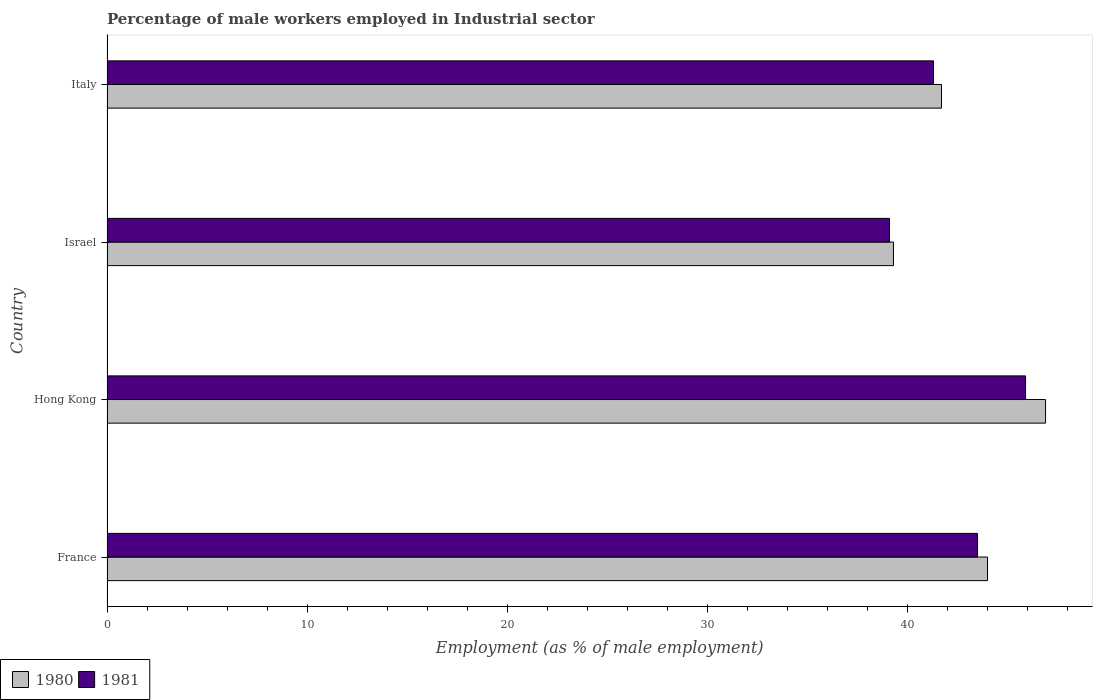How many different coloured bars are there?
Keep it short and to the point. 2. Are the number of bars on each tick of the Y-axis equal?
Ensure brevity in your answer.  Yes. How many bars are there on the 3rd tick from the bottom?
Offer a very short reply. 2. What is the label of the 4th group of bars from the top?
Your answer should be compact. France. In how many cases, is the number of bars for a given country not equal to the number of legend labels?
Keep it short and to the point. 0. What is the percentage of male workers employed in Industrial sector in 1981 in Hong Kong?
Provide a short and direct response. 45.9. Across all countries, what is the maximum percentage of male workers employed in Industrial sector in 1981?
Make the answer very short. 45.9. Across all countries, what is the minimum percentage of male workers employed in Industrial sector in 1980?
Offer a terse response. 39.3. In which country was the percentage of male workers employed in Industrial sector in 1981 maximum?
Ensure brevity in your answer.  Hong Kong. What is the total percentage of male workers employed in Industrial sector in 1981 in the graph?
Your answer should be compact. 169.8. What is the difference between the percentage of male workers employed in Industrial sector in 1981 in Israel and that in Italy?
Provide a short and direct response. -2.2. What is the difference between the percentage of male workers employed in Industrial sector in 1980 in Hong Kong and the percentage of male workers employed in Industrial sector in 1981 in Italy?
Your response must be concise. 5.6. What is the average percentage of male workers employed in Industrial sector in 1980 per country?
Your answer should be compact. 42.98. In how many countries, is the percentage of male workers employed in Industrial sector in 1980 greater than 34 %?
Ensure brevity in your answer.  4. What is the ratio of the percentage of male workers employed in Industrial sector in 1980 in Israel to that in Italy?
Provide a succinct answer. 0.94. Is the percentage of male workers employed in Industrial sector in 1981 in Israel less than that in Italy?
Your response must be concise. Yes. Is the difference between the percentage of male workers employed in Industrial sector in 1981 in France and Israel greater than the difference between the percentage of male workers employed in Industrial sector in 1980 in France and Israel?
Your answer should be very brief. No. What is the difference between the highest and the second highest percentage of male workers employed in Industrial sector in 1980?
Make the answer very short. 2.9. What is the difference between the highest and the lowest percentage of male workers employed in Industrial sector in 1981?
Ensure brevity in your answer.  6.8. In how many countries, is the percentage of male workers employed in Industrial sector in 1981 greater than the average percentage of male workers employed in Industrial sector in 1981 taken over all countries?
Ensure brevity in your answer.  2. Is the sum of the percentage of male workers employed in Industrial sector in 1981 in Hong Kong and Israel greater than the maximum percentage of male workers employed in Industrial sector in 1980 across all countries?
Provide a succinct answer. Yes. What does the 1st bar from the top in Italy represents?
Your answer should be very brief. 1981. How many bars are there?
Provide a short and direct response. 8. Are all the bars in the graph horizontal?
Keep it short and to the point. Yes. How are the legend labels stacked?
Make the answer very short. Horizontal. What is the title of the graph?
Your answer should be very brief. Percentage of male workers employed in Industrial sector. What is the label or title of the X-axis?
Make the answer very short. Employment (as % of male employment). What is the Employment (as % of male employment) in 1980 in France?
Offer a terse response. 44. What is the Employment (as % of male employment) in 1981 in France?
Make the answer very short. 43.5. What is the Employment (as % of male employment) of 1980 in Hong Kong?
Keep it short and to the point. 46.9. What is the Employment (as % of male employment) in 1981 in Hong Kong?
Make the answer very short. 45.9. What is the Employment (as % of male employment) of 1980 in Israel?
Keep it short and to the point. 39.3. What is the Employment (as % of male employment) of 1981 in Israel?
Ensure brevity in your answer.  39.1. What is the Employment (as % of male employment) of 1980 in Italy?
Provide a short and direct response. 41.7. What is the Employment (as % of male employment) in 1981 in Italy?
Make the answer very short. 41.3. Across all countries, what is the maximum Employment (as % of male employment) in 1980?
Offer a terse response. 46.9. Across all countries, what is the maximum Employment (as % of male employment) of 1981?
Provide a short and direct response. 45.9. Across all countries, what is the minimum Employment (as % of male employment) of 1980?
Your answer should be very brief. 39.3. Across all countries, what is the minimum Employment (as % of male employment) in 1981?
Give a very brief answer. 39.1. What is the total Employment (as % of male employment) of 1980 in the graph?
Offer a very short reply. 171.9. What is the total Employment (as % of male employment) in 1981 in the graph?
Keep it short and to the point. 169.8. What is the difference between the Employment (as % of male employment) of 1981 in France and that in Hong Kong?
Offer a terse response. -2.4. What is the difference between the Employment (as % of male employment) of 1980 in France and that in Israel?
Give a very brief answer. 4.7. What is the difference between the Employment (as % of male employment) of 1980 in France and that in Italy?
Your response must be concise. 2.3. What is the difference between the Employment (as % of male employment) in 1980 in Hong Kong and that in Israel?
Ensure brevity in your answer.  7.6. What is the difference between the Employment (as % of male employment) of 1981 in Hong Kong and that in Israel?
Make the answer very short. 6.8. What is the difference between the Employment (as % of male employment) in 1980 in Hong Kong and that in Italy?
Your answer should be very brief. 5.2. What is the difference between the Employment (as % of male employment) in 1980 in Israel and that in Italy?
Offer a very short reply. -2.4. What is the difference between the Employment (as % of male employment) of 1981 in Israel and that in Italy?
Make the answer very short. -2.2. What is the difference between the Employment (as % of male employment) of 1980 in France and the Employment (as % of male employment) of 1981 in Israel?
Provide a short and direct response. 4.9. What is the difference between the Employment (as % of male employment) in 1980 in Hong Kong and the Employment (as % of male employment) in 1981 in Israel?
Provide a short and direct response. 7.8. What is the difference between the Employment (as % of male employment) in 1980 in Hong Kong and the Employment (as % of male employment) in 1981 in Italy?
Make the answer very short. 5.6. What is the difference between the Employment (as % of male employment) in 1980 in Israel and the Employment (as % of male employment) in 1981 in Italy?
Your answer should be very brief. -2. What is the average Employment (as % of male employment) in 1980 per country?
Give a very brief answer. 42.98. What is the average Employment (as % of male employment) of 1981 per country?
Offer a terse response. 42.45. What is the difference between the Employment (as % of male employment) in 1980 and Employment (as % of male employment) in 1981 in France?
Provide a succinct answer. 0.5. What is the ratio of the Employment (as % of male employment) of 1980 in France to that in Hong Kong?
Give a very brief answer. 0.94. What is the ratio of the Employment (as % of male employment) in 1981 in France to that in Hong Kong?
Keep it short and to the point. 0.95. What is the ratio of the Employment (as % of male employment) in 1980 in France to that in Israel?
Make the answer very short. 1.12. What is the ratio of the Employment (as % of male employment) of 1981 in France to that in Israel?
Offer a very short reply. 1.11. What is the ratio of the Employment (as % of male employment) in 1980 in France to that in Italy?
Offer a very short reply. 1.06. What is the ratio of the Employment (as % of male employment) in 1981 in France to that in Italy?
Offer a terse response. 1.05. What is the ratio of the Employment (as % of male employment) of 1980 in Hong Kong to that in Israel?
Make the answer very short. 1.19. What is the ratio of the Employment (as % of male employment) of 1981 in Hong Kong to that in Israel?
Keep it short and to the point. 1.17. What is the ratio of the Employment (as % of male employment) in 1980 in Hong Kong to that in Italy?
Your answer should be very brief. 1.12. What is the ratio of the Employment (as % of male employment) in 1981 in Hong Kong to that in Italy?
Your answer should be very brief. 1.11. What is the ratio of the Employment (as % of male employment) of 1980 in Israel to that in Italy?
Keep it short and to the point. 0.94. What is the ratio of the Employment (as % of male employment) in 1981 in Israel to that in Italy?
Provide a succinct answer. 0.95. What is the difference between the highest and the second highest Employment (as % of male employment) of 1981?
Keep it short and to the point. 2.4. What is the difference between the highest and the lowest Employment (as % of male employment) in 1980?
Your answer should be very brief. 7.6. 